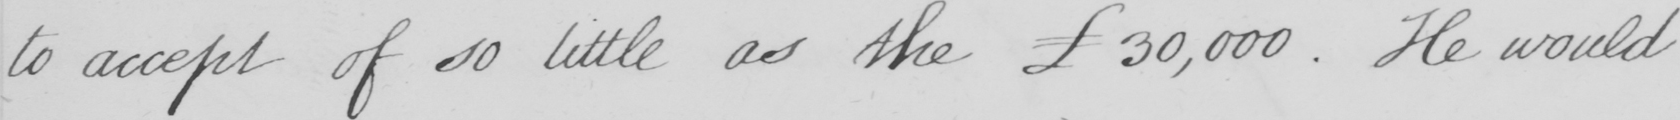What does this handwritten line say? to accept of so little as the £30,000 . He would 